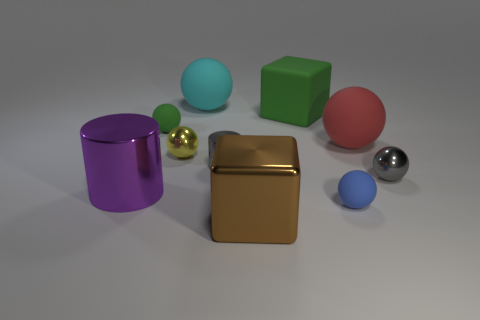What is the color of the tiny shiny ball that is left of the large sphere that is to the right of the big matte ball on the left side of the big red sphere?
Your response must be concise. Yellow. What number of objects are large cubes that are in front of the green rubber ball or matte balls right of the gray metal cylinder?
Your answer should be compact. 3. What number of other objects are the same color as the large cylinder?
Make the answer very short. 0. There is a large matte thing that is in front of the green block; is its shape the same as the large green object?
Provide a short and direct response. No. Is the number of green rubber objects that are in front of the gray cylinder less than the number of tiny rubber objects?
Offer a very short reply. Yes. Are there any large cyan cylinders that have the same material as the tiny gray cylinder?
Make the answer very short. No. There is a red thing that is the same size as the shiny cube; what is it made of?
Make the answer very short. Rubber. Are there fewer matte things that are to the right of the cyan sphere than large cyan matte things that are in front of the small blue ball?
Ensure brevity in your answer.  No. There is a big object that is both in front of the red matte object and behind the shiny block; what shape is it?
Keep it short and to the point. Cylinder. How many big brown metal things have the same shape as the yellow metal object?
Provide a succinct answer. 0. 